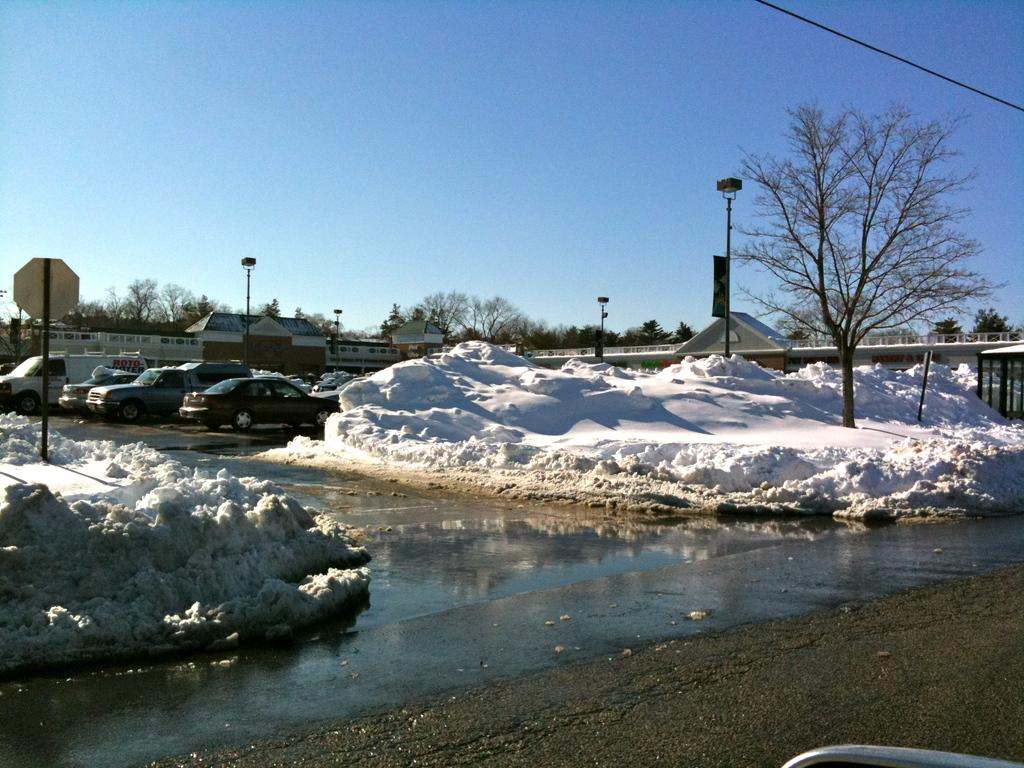What is the main feature of the image? There is a road in the image. What can be seen alongside the road? Cars are parked on the side of the road. What is the weather condition in the image? Snow is collected and kept aside, indicating a snowy environment. What type of vegetation is present in the image? There are trees in the image. What type of structures can be seen in the image? There are buildings in the image. What is visible in the background of the image? The sky is visible in the background of the image. How many birds are sitting on the farmer's hat in the image? There are no birds or farmers present in the image. What is the level of noise in the image? The image does not provide information about the noise level, as it focuses on the visual elements. 